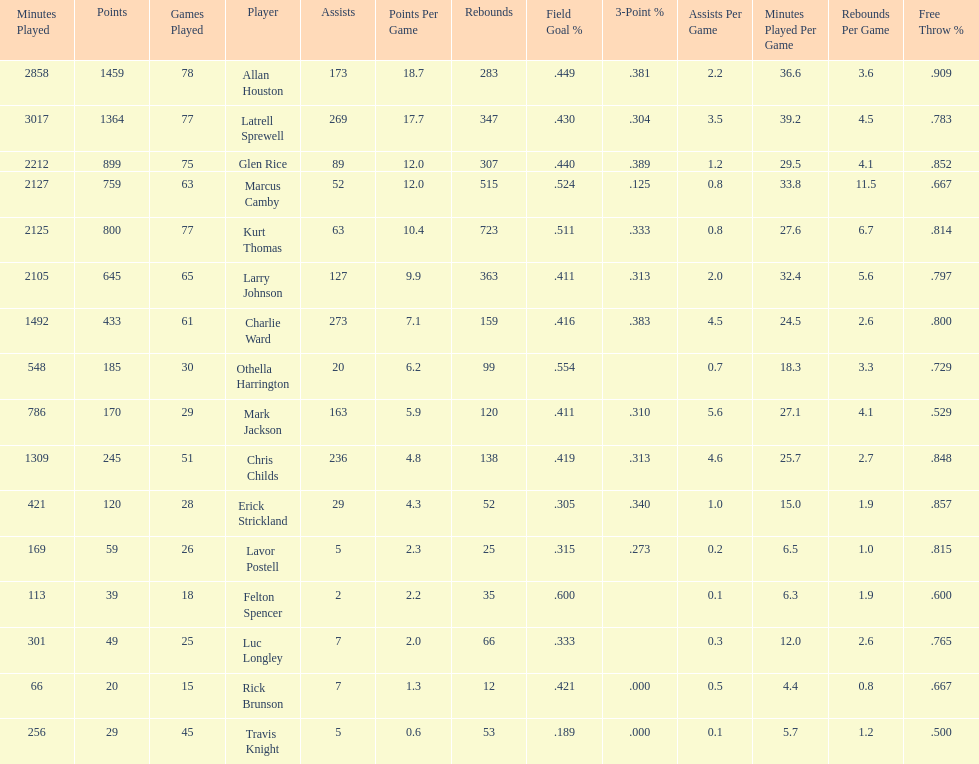How many games did larry johnson play? 65. 